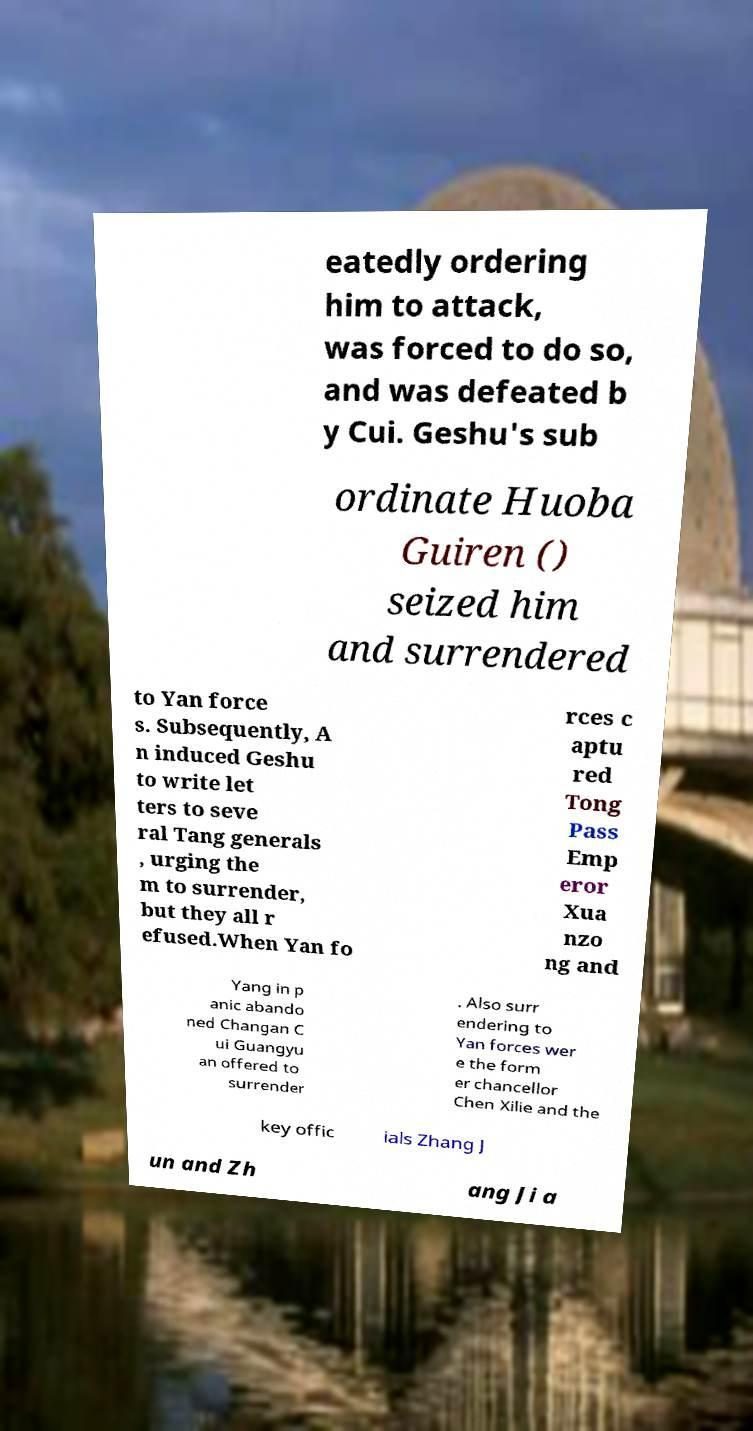Can you accurately transcribe the text from the provided image for me? eatedly ordering him to attack, was forced to do so, and was defeated b y Cui. Geshu's sub ordinate Huoba Guiren () seized him and surrendered to Yan force s. Subsequently, A n induced Geshu to write let ters to seve ral Tang generals , urging the m to surrender, but they all r efused.When Yan fo rces c aptu red Tong Pass Emp eror Xua nzo ng and Yang in p anic abando ned Changan C ui Guangyu an offered to surrender . Also surr endering to Yan forces wer e the form er chancellor Chen Xilie and the key offic ials Zhang J un and Zh ang Ji a 